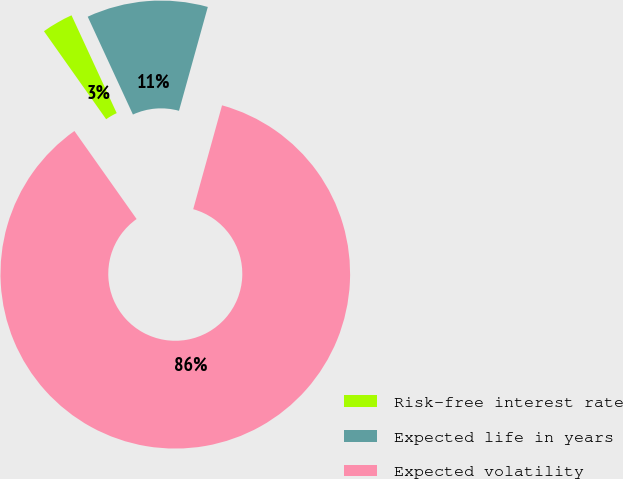Convert chart. <chart><loc_0><loc_0><loc_500><loc_500><pie_chart><fcel>Risk-free interest rate<fcel>Expected life in years<fcel>Expected volatility<nl><fcel>2.9%<fcel>11.2%<fcel>85.9%<nl></chart> 